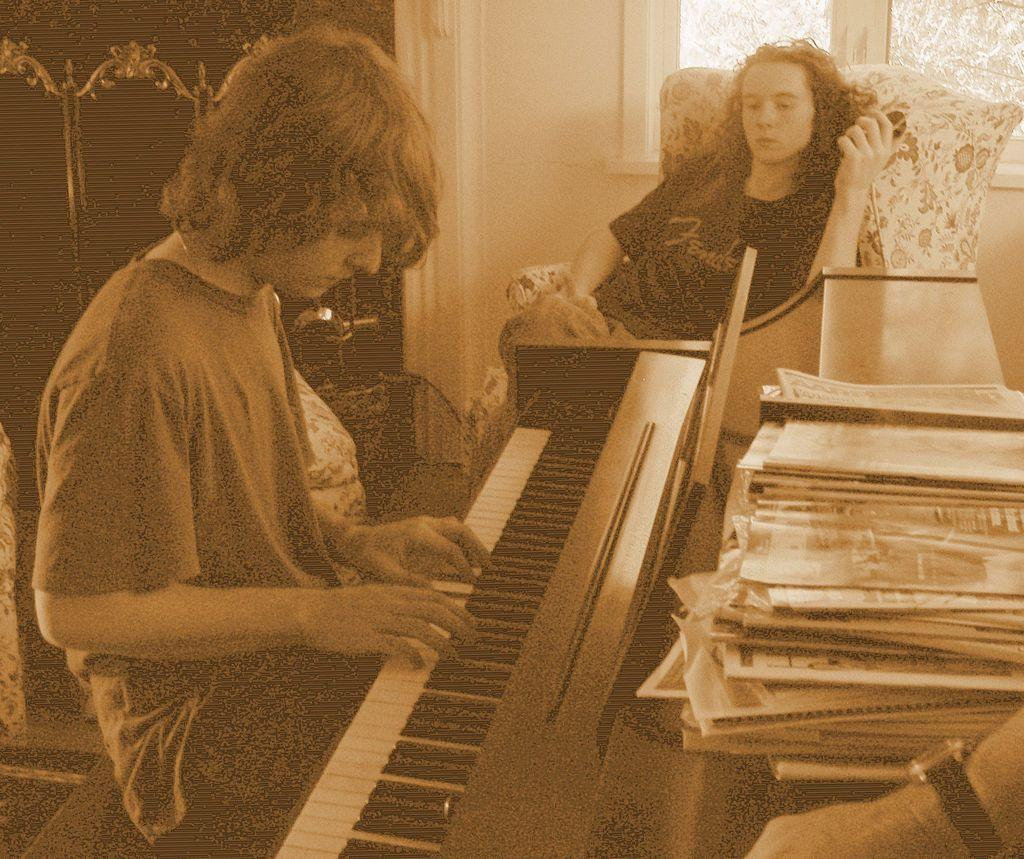How many people are sitting in the image? There are two persons sitting on chairs in the image. What is one of the persons doing? One person is playing the piano. Are there any objects on the piano? Yes, there are books on the piano. What can be seen in the background of the image? There is a wall and a window in the background. What type of doll is sitting on the judge's lap in the image? There is no doll or judge present in the image; it features two persons sitting on chairs and one playing the piano. 